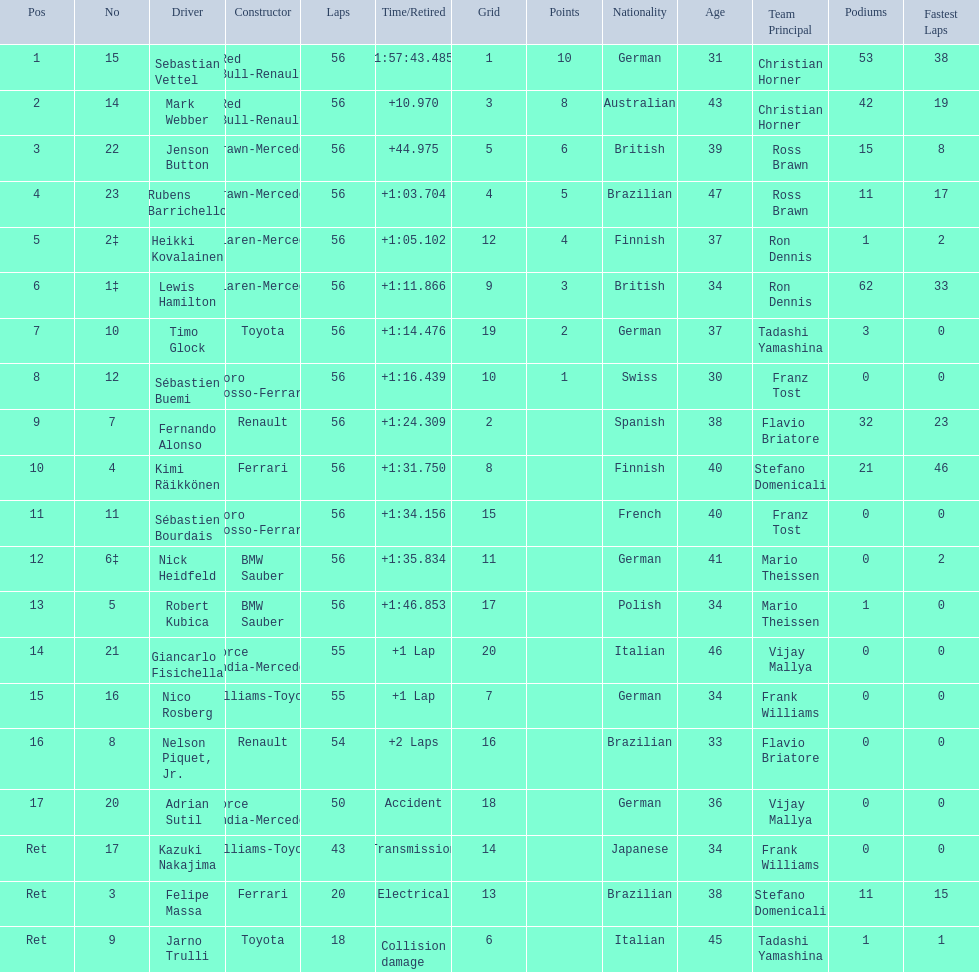Which drivers raced in the 2009 chinese grand prix? Sebastian Vettel, Mark Webber, Jenson Button, Rubens Barrichello, Heikki Kovalainen, Lewis Hamilton, Timo Glock, Sébastien Buemi, Fernando Alonso, Kimi Räikkönen, Sébastien Bourdais, Nick Heidfeld, Robert Kubica, Giancarlo Fisichella, Nico Rosberg, Nelson Piquet, Jr., Adrian Sutil, Kazuki Nakajima, Felipe Massa, Jarno Trulli. Of the drivers in the 2009 chinese grand prix, which finished the race? Sebastian Vettel, Mark Webber, Jenson Button, Rubens Barrichello, Heikki Kovalainen, Lewis Hamilton, Timo Glock, Sébastien Buemi, Fernando Alonso, Kimi Räikkönen, Sébastien Bourdais, Nick Heidfeld, Robert Kubica. Of the drivers who finished the race, who had the slowest time? Robert Kubica. 